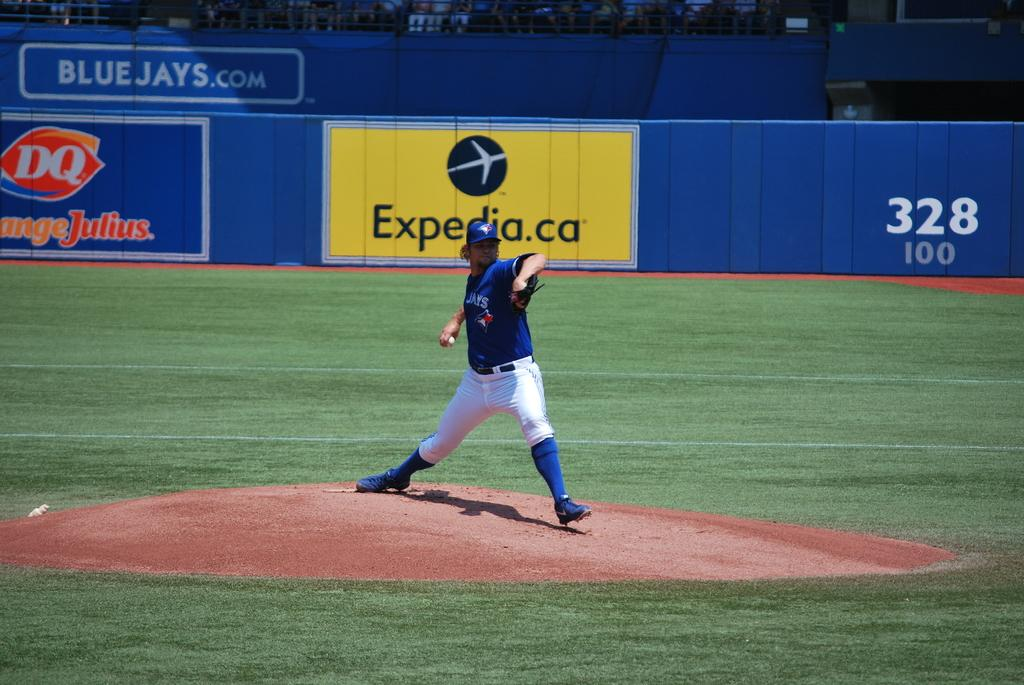What is the main subject of the image? There is a person standing in the image. What is the person wearing? The person is wearing a blue and white color dress. What can be seen in the background of the image? There is a blue-colored board in the background of the image. Is the person holding a rake in the image? There is no rake present in the image. 